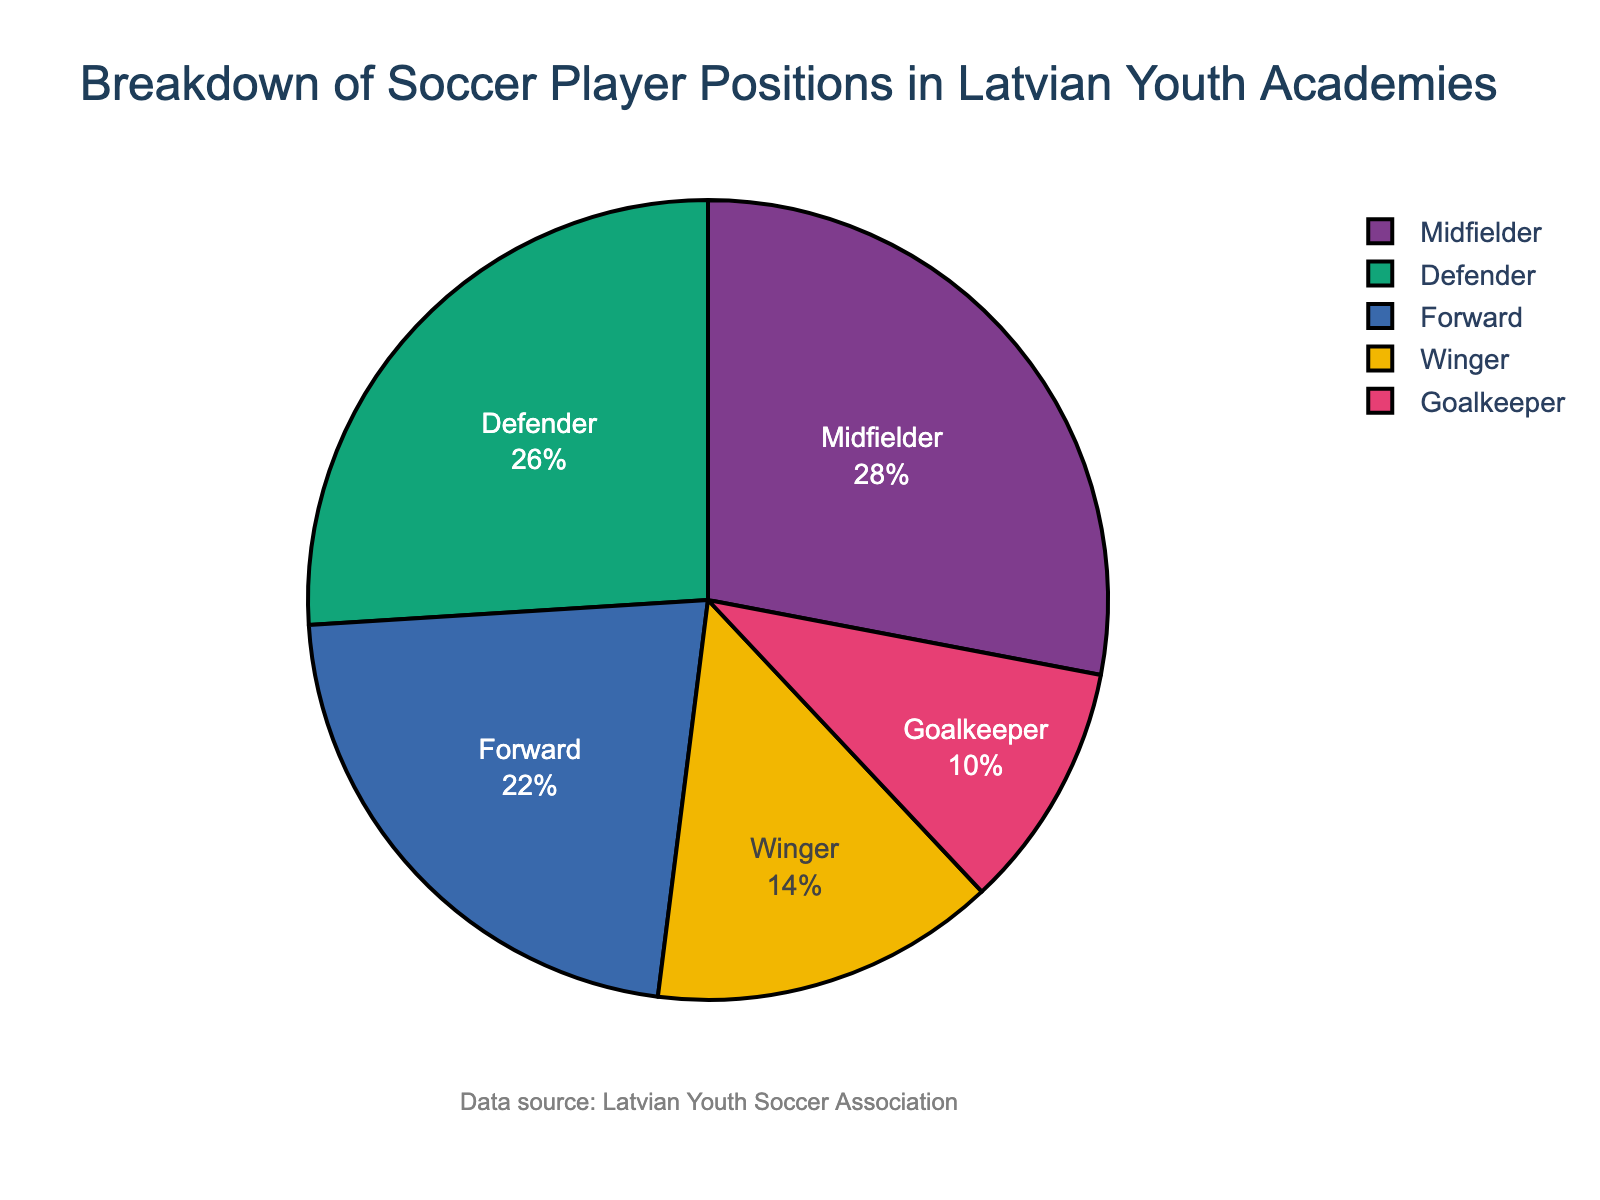Which position has the highest percentage of players in Latvian youth academies? Look at the pie chart to find the position that takes up the largest segment. The midfielder's segment is the largest.
Answer: Midfielder What is the combined percentage of Goalkeepers and Wingers? Add the percentages of Goalkeepers and Wingers. Goalkeepers have 10% and Wingers have 14%. 10% + 14% = 24%.
Answer: 24% Is the percentage of Defenders greater than Forwards? Compare the percentages of Defenders (26%) and Forwards (22%). 26% is greater than 22%.
Answer: Yes How much more percentage do Midfielders have compared to Forwards? Subtract the percentage of Forwards (22%) from the percentage of Midfielders (28%). 28% - 22% = 6%.
Answer: 6% Which position has the smallest percentage of players? Look at the pie chart to find the position with the smallest segment. The Goalkeeper's segment is the smallest.
Answer: Goalkeeper What is the difference in percentage between Defenders and Wingers? Subtract the percentage of Wingers (14%) from the percentage of Defenders (26%). 26% - 14% = 12%.
Answer: 12% Is the percentage of Midfielders more than double the percentage of Goalkeepers? Double the percentage of Goalkeepers (10% * 2 = 20%) and compare it to the percentage of Midfielders (28%). 28% is more than 20%.
Answer: Yes What percentage of players play in positions other than Forward and Midfielders? Subtract the combined percentage of Forwards (22%) and Midfielders (28%) from 100%. 100% - (22% + 28%) = 50%.
Answer: 50% Are there more players in the Defenders position than in Wingers and Goalkeepers combined? Add the percentages of Wingers (14%) and Goalkeepers (10%) and compare to Defenders (26%). 14% + 10% = 24%, which is less than 26%.
Answer: Yes Which positions together make up more than half of the players in Latvian youth academies? List the positions and their percentages, then find the combination that exceeds 50%. Midfielders (28%) and Defenders (26%) together make up 28% + 26% = 54%.
Answer: Midfielder and Defender 